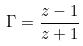Convert formula to latex. <formula><loc_0><loc_0><loc_500><loc_500>\Gamma = \frac { z - 1 } { z + 1 }</formula> 